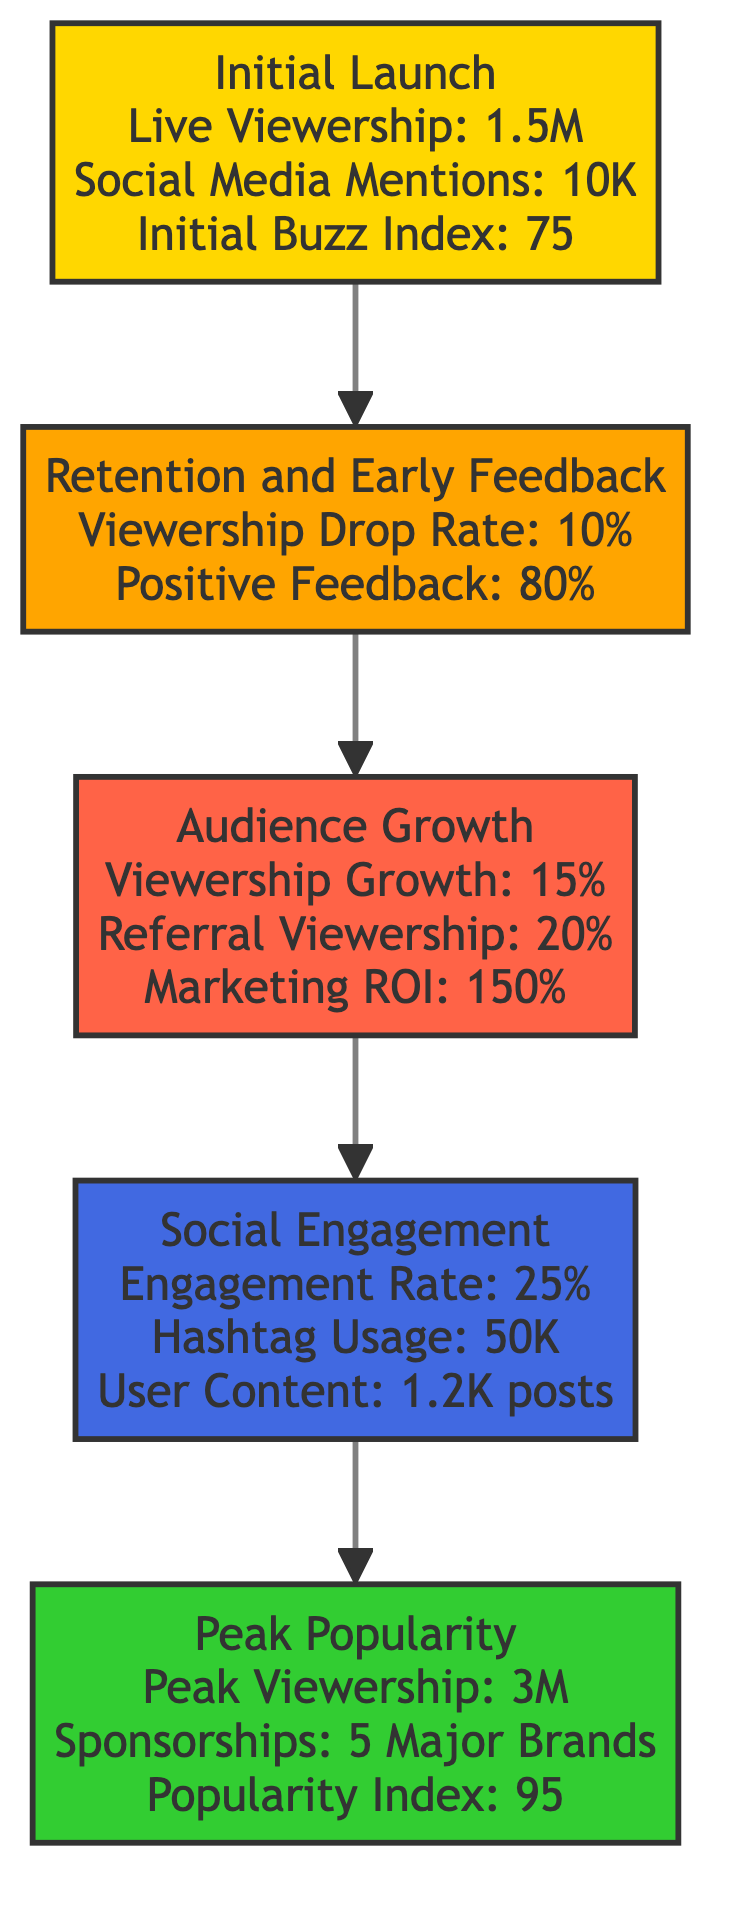What is the initial buzz index at the launch? The diagram shows that the initial buzz index during the launch is listed as 75. This information is found in the "Initial Launch" box.
Answer: 75 What is the peak viewership mentioned? Referring to the "Peak Popularity" node in the diagram, it states that the peak viewership reached 3 million. This is a directly cited metric from that level.
Answer: 3 million What percentage of positive feedback was recorded in the early feedback stage? The "Retention and Early Feedback" node indicates a positive feedback percentage of 80%. This is a specific metric highlighted in that segment of the flowchart.
Answer: 80% What are the critical issues reported during early feedback? In the "Retention and Early Feedback" section, the critical issues reported are "Pacing" and "Segment Length." These are explicitly listed as concerns in that stage.
Answer: Pacing, Segment Length Which level has the highest engagement rate? The "Social Engagement and Interaction" section reveals a social engagement rate of 25%, which can be compared to other levels, as they provide different metrics, highlighting the flowchart's focus on increasing engagement.
Answer: 25% What is the relationship between audience growth and marketing impact? The "Audience Growth and Marketing Impact" node connects to the previous node, "Retention and Early Feedback," indicating that successful retention leads to growth in audience due to marketing. The 15% growth correlates with the previous audience satisfaction.
Answer: Growth → Retention How many major brands are mentioned in sponsorship deals? The "Peak Popularity" level lists that 5 major brands secured sponsorship deals. This figure is specified clearly within this top node of the flow chart.
Answer: 5 Major Brands What social media engagement metric is mentioned? The "Social Engagement and Interaction" node notes a social engagement rate of 25%. This particular metric is focused on measuring how actively viewers are interacting on social media platforms.
Answer: 25% Which stage of viewer engagement has the highest potential for growth? The diagram implies the "Audience Growth and Marketing Impact" level is critical for growth, reflected in its 15% average viewership growth rate and a marketing ROI of 150%, indicating significant potential for scaling viewership at this stage.
Answer: Audience Growth level 